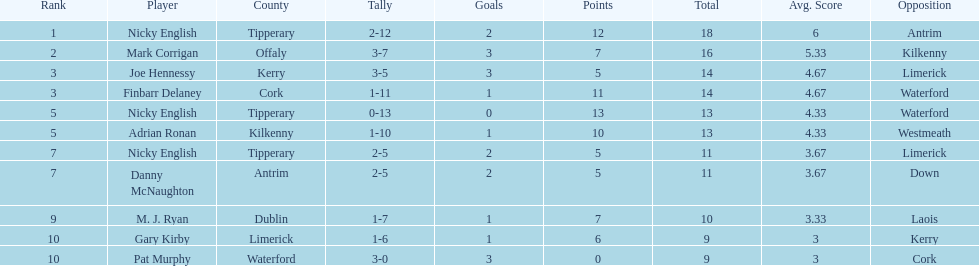Which player held the highest rank? Nicky English. Would you mind parsing the complete table? {'header': ['Rank', 'Player', 'County', 'Tally', 'Goals', 'Points', 'Total', 'Avg. Score', 'Opposition'], 'rows': [['1', 'Nicky English', 'Tipperary', '2-12', '2', '12', '18', '6', 'Antrim'], ['2', 'Mark Corrigan', 'Offaly', '3-7', '3', '7', '16', '5.33', 'Kilkenny'], ['3', 'Joe Hennessy', 'Kerry', '3-5', '3', '5', '14', '4.67', 'Limerick'], ['3', 'Finbarr Delaney', 'Cork', '1-11', '1', '11', '14', '4.67', 'Waterford'], ['5', 'Nicky English', 'Tipperary', '0-13', '0', '13', '13', '4.33', 'Waterford'], ['5', 'Adrian Ronan', 'Kilkenny', '1-10', '1', '10', '13', '4.33', 'Westmeath'], ['7', 'Nicky English', 'Tipperary', '2-5', '2', '5', '11', '3.67', 'Limerick'], ['7', 'Danny McNaughton', 'Antrim', '2-5', '2', '5', '11', '3.67', 'Down'], ['9', 'M. J. Ryan', 'Dublin', '1-7', '1', '7', '10', '3.33', 'Laois'], ['10', 'Gary Kirby', 'Limerick', '1-6', '1', '6', '9', '3', 'Kerry'], ['10', 'Pat Murphy', 'Waterford', '3-0', '3', '0', '9', '3', 'Cork']]} 